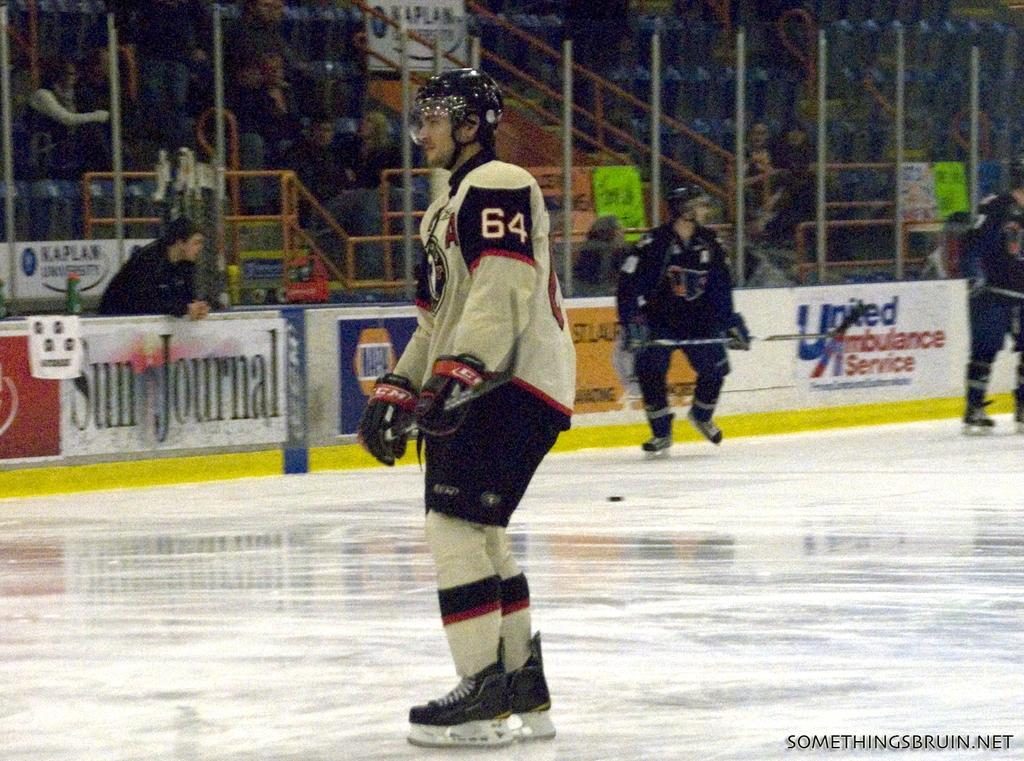<image>
Describe the image concisely. A hockey player stands in the center of teh hockey rink with the number 64 on his arm. 